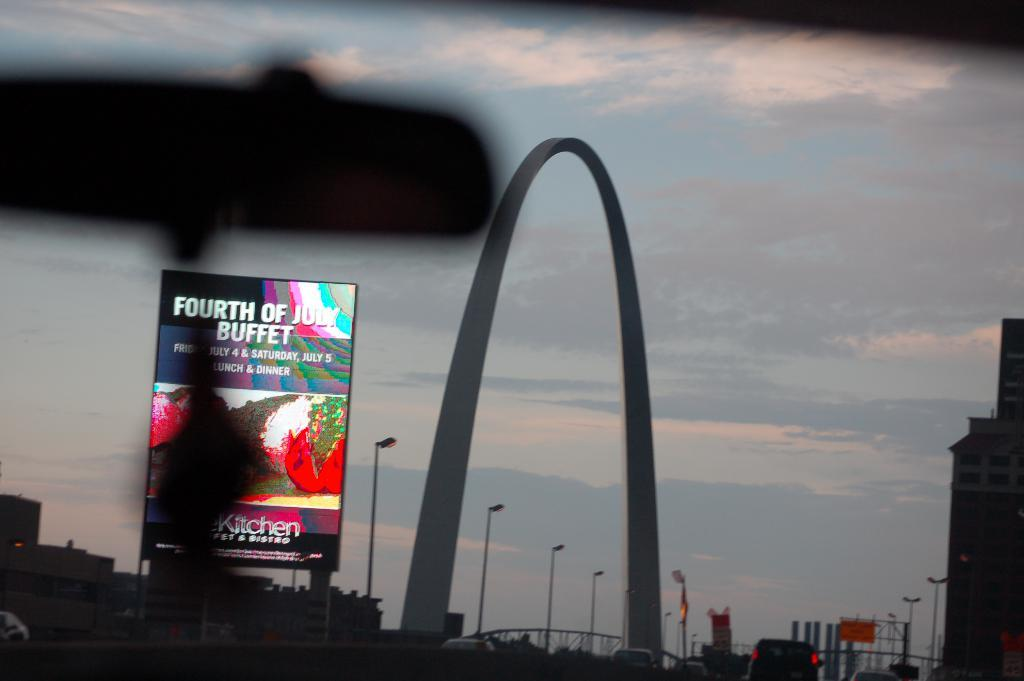<image>
Describe the image concisely. A large arch with a sign for a buffet on the left 